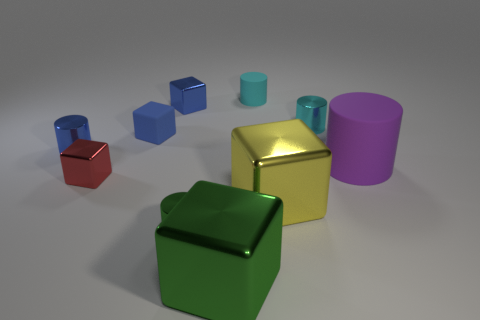Subtract all yellow shiny blocks. How many blocks are left? 4 Subtract all yellow blocks. How many blocks are left? 4 Subtract 3 cubes. How many cubes are left? 2 Subtract all large gray matte spheres. Subtract all small matte cylinders. How many objects are left? 9 Add 6 small cyan matte cylinders. How many small cyan matte cylinders are left? 7 Add 9 brown blocks. How many brown blocks exist? 9 Subtract 0 brown cubes. How many objects are left? 10 Subtract all cyan cylinders. Subtract all red balls. How many cylinders are left? 3 Subtract all green blocks. How many blue cylinders are left? 1 